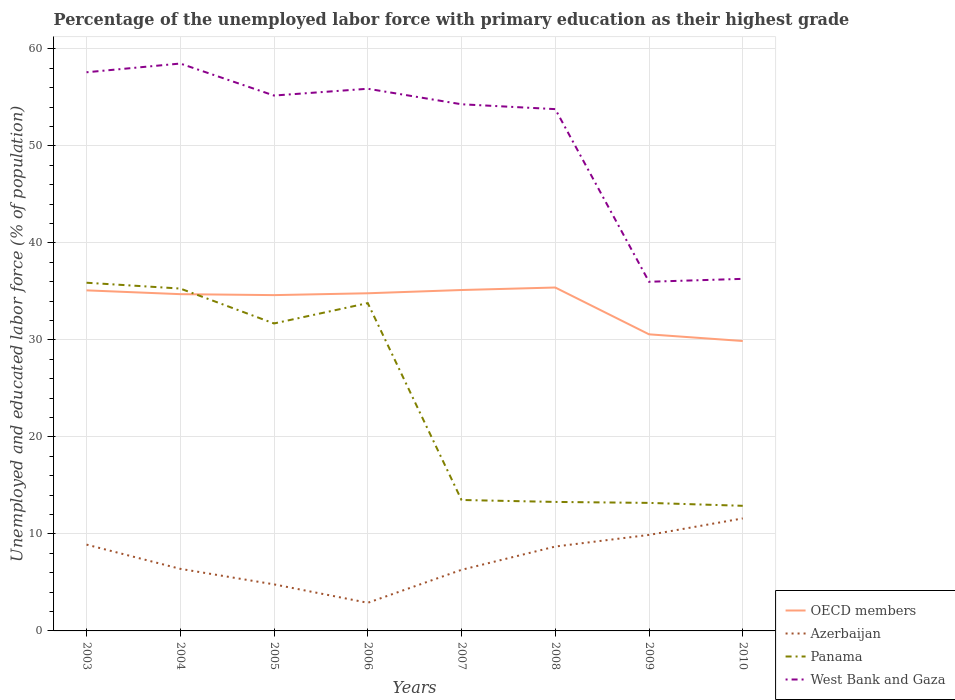How many different coloured lines are there?
Make the answer very short. 4. Is the number of lines equal to the number of legend labels?
Your answer should be very brief. Yes. What is the total percentage of the unemployed labor force with primary education in West Bank and Gaza in the graph?
Give a very brief answer. 21.6. What is the difference between the highest and the second highest percentage of the unemployed labor force with primary education in OECD members?
Ensure brevity in your answer.  5.51. Is the percentage of the unemployed labor force with primary education in OECD members strictly greater than the percentage of the unemployed labor force with primary education in West Bank and Gaza over the years?
Keep it short and to the point. Yes. How many lines are there?
Ensure brevity in your answer.  4. How many years are there in the graph?
Your answer should be compact. 8. Does the graph contain grids?
Your response must be concise. Yes. Where does the legend appear in the graph?
Provide a succinct answer. Bottom right. How many legend labels are there?
Make the answer very short. 4. What is the title of the graph?
Offer a very short reply. Percentage of the unemployed labor force with primary education as their highest grade. Does "Botswana" appear as one of the legend labels in the graph?
Ensure brevity in your answer.  No. What is the label or title of the Y-axis?
Your answer should be very brief. Unemployed and educated labor force (% of population). What is the Unemployed and educated labor force (% of population) in OECD members in 2003?
Offer a terse response. 35.11. What is the Unemployed and educated labor force (% of population) of Azerbaijan in 2003?
Keep it short and to the point. 8.9. What is the Unemployed and educated labor force (% of population) in Panama in 2003?
Make the answer very short. 35.9. What is the Unemployed and educated labor force (% of population) of West Bank and Gaza in 2003?
Your answer should be compact. 57.6. What is the Unemployed and educated labor force (% of population) of OECD members in 2004?
Provide a short and direct response. 34.72. What is the Unemployed and educated labor force (% of population) of Azerbaijan in 2004?
Provide a succinct answer. 6.4. What is the Unemployed and educated labor force (% of population) of Panama in 2004?
Your answer should be very brief. 35.3. What is the Unemployed and educated labor force (% of population) of West Bank and Gaza in 2004?
Your answer should be very brief. 58.5. What is the Unemployed and educated labor force (% of population) in OECD members in 2005?
Offer a terse response. 34.62. What is the Unemployed and educated labor force (% of population) of Azerbaijan in 2005?
Ensure brevity in your answer.  4.8. What is the Unemployed and educated labor force (% of population) in Panama in 2005?
Your answer should be compact. 31.7. What is the Unemployed and educated labor force (% of population) of West Bank and Gaza in 2005?
Your answer should be very brief. 55.2. What is the Unemployed and educated labor force (% of population) in OECD members in 2006?
Keep it short and to the point. 34.81. What is the Unemployed and educated labor force (% of population) in Azerbaijan in 2006?
Offer a very short reply. 2.9. What is the Unemployed and educated labor force (% of population) of Panama in 2006?
Ensure brevity in your answer.  33.8. What is the Unemployed and educated labor force (% of population) in West Bank and Gaza in 2006?
Your answer should be compact. 55.9. What is the Unemployed and educated labor force (% of population) of OECD members in 2007?
Offer a terse response. 35.15. What is the Unemployed and educated labor force (% of population) of Azerbaijan in 2007?
Keep it short and to the point. 6.3. What is the Unemployed and educated labor force (% of population) in Panama in 2007?
Provide a succinct answer. 13.5. What is the Unemployed and educated labor force (% of population) of West Bank and Gaza in 2007?
Keep it short and to the point. 54.3. What is the Unemployed and educated labor force (% of population) in OECD members in 2008?
Provide a short and direct response. 35.41. What is the Unemployed and educated labor force (% of population) of Azerbaijan in 2008?
Provide a succinct answer. 8.7. What is the Unemployed and educated labor force (% of population) of Panama in 2008?
Offer a terse response. 13.3. What is the Unemployed and educated labor force (% of population) of West Bank and Gaza in 2008?
Your answer should be very brief. 53.8. What is the Unemployed and educated labor force (% of population) in OECD members in 2009?
Offer a terse response. 30.58. What is the Unemployed and educated labor force (% of population) in Azerbaijan in 2009?
Give a very brief answer. 9.9. What is the Unemployed and educated labor force (% of population) of Panama in 2009?
Your answer should be very brief. 13.2. What is the Unemployed and educated labor force (% of population) of West Bank and Gaza in 2009?
Provide a short and direct response. 36. What is the Unemployed and educated labor force (% of population) of OECD members in 2010?
Give a very brief answer. 29.89. What is the Unemployed and educated labor force (% of population) in Azerbaijan in 2010?
Offer a terse response. 11.6. What is the Unemployed and educated labor force (% of population) in Panama in 2010?
Provide a succinct answer. 12.9. What is the Unemployed and educated labor force (% of population) of West Bank and Gaza in 2010?
Give a very brief answer. 36.3. Across all years, what is the maximum Unemployed and educated labor force (% of population) in OECD members?
Your response must be concise. 35.41. Across all years, what is the maximum Unemployed and educated labor force (% of population) in Azerbaijan?
Ensure brevity in your answer.  11.6. Across all years, what is the maximum Unemployed and educated labor force (% of population) of Panama?
Provide a short and direct response. 35.9. Across all years, what is the maximum Unemployed and educated labor force (% of population) in West Bank and Gaza?
Your answer should be very brief. 58.5. Across all years, what is the minimum Unemployed and educated labor force (% of population) in OECD members?
Provide a short and direct response. 29.89. Across all years, what is the minimum Unemployed and educated labor force (% of population) of Azerbaijan?
Your answer should be compact. 2.9. Across all years, what is the minimum Unemployed and educated labor force (% of population) of Panama?
Your answer should be compact. 12.9. What is the total Unemployed and educated labor force (% of population) in OECD members in the graph?
Provide a succinct answer. 270.3. What is the total Unemployed and educated labor force (% of population) of Azerbaijan in the graph?
Keep it short and to the point. 59.5. What is the total Unemployed and educated labor force (% of population) in Panama in the graph?
Offer a very short reply. 189.6. What is the total Unemployed and educated labor force (% of population) of West Bank and Gaza in the graph?
Provide a short and direct response. 407.6. What is the difference between the Unemployed and educated labor force (% of population) of OECD members in 2003 and that in 2004?
Your response must be concise. 0.39. What is the difference between the Unemployed and educated labor force (% of population) of Azerbaijan in 2003 and that in 2004?
Provide a succinct answer. 2.5. What is the difference between the Unemployed and educated labor force (% of population) of Panama in 2003 and that in 2004?
Your response must be concise. 0.6. What is the difference between the Unemployed and educated labor force (% of population) of OECD members in 2003 and that in 2005?
Give a very brief answer. 0.49. What is the difference between the Unemployed and educated labor force (% of population) of Azerbaijan in 2003 and that in 2005?
Your response must be concise. 4.1. What is the difference between the Unemployed and educated labor force (% of population) of Panama in 2003 and that in 2005?
Your answer should be compact. 4.2. What is the difference between the Unemployed and educated labor force (% of population) in OECD members in 2003 and that in 2006?
Offer a terse response. 0.3. What is the difference between the Unemployed and educated labor force (% of population) in Panama in 2003 and that in 2006?
Provide a succinct answer. 2.1. What is the difference between the Unemployed and educated labor force (% of population) of West Bank and Gaza in 2003 and that in 2006?
Keep it short and to the point. 1.7. What is the difference between the Unemployed and educated labor force (% of population) in OECD members in 2003 and that in 2007?
Give a very brief answer. -0.04. What is the difference between the Unemployed and educated labor force (% of population) in Panama in 2003 and that in 2007?
Your answer should be very brief. 22.4. What is the difference between the Unemployed and educated labor force (% of population) in West Bank and Gaza in 2003 and that in 2007?
Offer a very short reply. 3.3. What is the difference between the Unemployed and educated labor force (% of population) of OECD members in 2003 and that in 2008?
Provide a succinct answer. -0.29. What is the difference between the Unemployed and educated labor force (% of population) in Panama in 2003 and that in 2008?
Your answer should be very brief. 22.6. What is the difference between the Unemployed and educated labor force (% of population) of OECD members in 2003 and that in 2009?
Provide a short and direct response. 4.53. What is the difference between the Unemployed and educated labor force (% of population) in Azerbaijan in 2003 and that in 2009?
Provide a short and direct response. -1. What is the difference between the Unemployed and educated labor force (% of population) of Panama in 2003 and that in 2009?
Offer a terse response. 22.7. What is the difference between the Unemployed and educated labor force (% of population) in West Bank and Gaza in 2003 and that in 2009?
Your answer should be compact. 21.6. What is the difference between the Unemployed and educated labor force (% of population) in OECD members in 2003 and that in 2010?
Offer a terse response. 5.22. What is the difference between the Unemployed and educated labor force (% of population) of Panama in 2003 and that in 2010?
Provide a succinct answer. 23. What is the difference between the Unemployed and educated labor force (% of population) in West Bank and Gaza in 2003 and that in 2010?
Make the answer very short. 21.3. What is the difference between the Unemployed and educated labor force (% of population) in OECD members in 2004 and that in 2005?
Your answer should be very brief. 0.1. What is the difference between the Unemployed and educated labor force (% of population) of OECD members in 2004 and that in 2006?
Provide a succinct answer. -0.09. What is the difference between the Unemployed and educated labor force (% of population) of Azerbaijan in 2004 and that in 2006?
Offer a terse response. 3.5. What is the difference between the Unemployed and educated labor force (% of population) of West Bank and Gaza in 2004 and that in 2006?
Ensure brevity in your answer.  2.6. What is the difference between the Unemployed and educated labor force (% of population) in OECD members in 2004 and that in 2007?
Provide a succinct answer. -0.43. What is the difference between the Unemployed and educated labor force (% of population) of Panama in 2004 and that in 2007?
Provide a succinct answer. 21.8. What is the difference between the Unemployed and educated labor force (% of population) in OECD members in 2004 and that in 2008?
Your answer should be compact. -0.68. What is the difference between the Unemployed and educated labor force (% of population) in Azerbaijan in 2004 and that in 2008?
Provide a short and direct response. -2.3. What is the difference between the Unemployed and educated labor force (% of population) of OECD members in 2004 and that in 2009?
Keep it short and to the point. 4.14. What is the difference between the Unemployed and educated labor force (% of population) of Panama in 2004 and that in 2009?
Your answer should be very brief. 22.1. What is the difference between the Unemployed and educated labor force (% of population) of West Bank and Gaza in 2004 and that in 2009?
Keep it short and to the point. 22.5. What is the difference between the Unemployed and educated labor force (% of population) of OECD members in 2004 and that in 2010?
Offer a very short reply. 4.83. What is the difference between the Unemployed and educated labor force (% of population) of Azerbaijan in 2004 and that in 2010?
Ensure brevity in your answer.  -5.2. What is the difference between the Unemployed and educated labor force (% of population) of Panama in 2004 and that in 2010?
Your answer should be very brief. 22.4. What is the difference between the Unemployed and educated labor force (% of population) in West Bank and Gaza in 2004 and that in 2010?
Keep it short and to the point. 22.2. What is the difference between the Unemployed and educated labor force (% of population) of OECD members in 2005 and that in 2006?
Your answer should be very brief. -0.19. What is the difference between the Unemployed and educated labor force (% of population) in Azerbaijan in 2005 and that in 2006?
Your answer should be compact. 1.9. What is the difference between the Unemployed and educated labor force (% of population) in Panama in 2005 and that in 2006?
Your response must be concise. -2.1. What is the difference between the Unemployed and educated labor force (% of population) in West Bank and Gaza in 2005 and that in 2006?
Provide a short and direct response. -0.7. What is the difference between the Unemployed and educated labor force (% of population) of OECD members in 2005 and that in 2007?
Ensure brevity in your answer.  -0.53. What is the difference between the Unemployed and educated labor force (% of population) of Panama in 2005 and that in 2007?
Your answer should be compact. 18.2. What is the difference between the Unemployed and educated labor force (% of population) of West Bank and Gaza in 2005 and that in 2007?
Keep it short and to the point. 0.9. What is the difference between the Unemployed and educated labor force (% of population) of OECD members in 2005 and that in 2008?
Provide a short and direct response. -0.78. What is the difference between the Unemployed and educated labor force (% of population) in Azerbaijan in 2005 and that in 2008?
Provide a short and direct response. -3.9. What is the difference between the Unemployed and educated labor force (% of population) of Panama in 2005 and that in 2008?
Your answer should be compact. 18.4. What is the difference between the Unemployed and educated labor force (% of population) of OECD members in 2005 and that in 2009?
Your answer should be very brief. 4.04. What is the difference between the Unemployed and educated labor force (% of population) in Azerbaijan in 2005 and that in 2009?
Give a very brief answer. -5.1. What is the difference between the Unemployed and educated labor force (% of population) of West Bank and Gaza in 2005 and that in 2009?
Provide a succinct answer. 19.2. What is the difference between the Unemployed and educated labor force (% of population) of OECD members in 2005 and that in 2010?
Offer a very short reply. 4.73. What is the difference between the Unemployed and educated labor force (% of population) of Azerbaijan in 2005 and that in 2010?
Offer a terse response. -6.8. What is the difference between the Unemployed and educated labor force (% of population) in Panama in 2005 and that in 2010?
Provide a succinct answer. 18.8. What is the difference between the Unemployed and educated labor force (% of population) of West Bank and Gaza in 2005 and that in 2010?
Offer a very short reply. 18.9. What is the difference between the Unemployed and educated labor force (% of population) in OECD members in 2006 and that in 2007?
Provide a succinct answer. -0.34. What is the difference between the Unemployed and educated labor force (% of population) in Azerbaijan in 2006 and that in 2007?
Offer a terse response. -3.4. What is the difference between the Unemployed and educated labor force (% of population) of Panama in 2006 and that in 2007?
Your answer should be very brief. 20.3. What is the difference between the Unemployed and educated labor force (% of population) of West Bank and Gaza in 2006 and that in 2007?
Provide a short and direct response. 1.6. What is the difference between the Unemployed and educated labor force (% of population) in OECD members in 2006 and that in 2008?
Offer a very short reply. -0.59. What is the difference between the Unemployed and educated labor force (% of population) in Panama in 2006 and that in 2008?
Your answer should be very brief. 20.5. What is the difference between the Unemployed and educated labor force (% of population) in OECD members in 2006 and that in 2009?
Give a very brief answer. 4.23. What is the difference between the Unemployed and educated labor force (% of population) in Azerbaijan in 2006 and that in 2009?
Offer a terse response. -7. What is the difference between the Unemployed and educated labor force (% of population) in Panama in 2006 and that in 2009?
Offer a terse response. 20.6. What is the difference between the Unemployed and educated labor force (% of population) in OECD members in 2006 and that in 2010?
Provide a succinct answer. 4.92. What is the difference between the Unemployed and educated labor force (% of population) in Azerbaijan in 2006 and that in 2010?
Offer a very short reply. -8.7. What is the difference between the Unemployed and educated labor force (% of population) in Panama in 2006 and that in 2010?
Offer a very short reply. 20.9. What is the difference between the Unemployed and educated labor force (% of population) of West Bank and Gaza in 2006 and that in 2010?
Your answer should be very brief. 19.6. What is the difference between the Unemployed and educated labor force (% of population) of OECD members in 2007 and that in 2008?
Give a very brief answer. -0.26. What is the difference between the Unemployed and educated labor force (% of population) of West Bank and Gaza in 2007 and that in 2008?
Offer a very short reply. 0.5. What is the difference between the Unemployed and educated labor force (% of population) of OECD members in 2007 and that in 2009?
Your response must be concise. 4.57. What is the difference between the Unemployed and educated labor force (% of population) of Panama in 2007 and that in 2009?
Ensure brevity in your answer.  0.3. What is the difference between the Unemployed and educated labor force (% of population) in OECD members in 2007 and that in 2010?
Your response must be concise. 5.26. What is the difference between the Unemployed and educated labor force (% of population) in Panama in 2007 and that in 2010?
Give a very brief answer. 0.6. What is the difference between the Unemployed and educated labor force (% of population) in OECD members in 2008 and that in 2009?
Provide a succinct answer. 4.83. What is the difference between the Unemployed and educated labor force (% of population) of OECD members in 2008 and that in 2010?
Your answer should be compact. 5.51. What is the difference between the Unemployed and educated labor force (% of population) in Azerbaijan in 2008 and that in 2010?
Make the answer very short. -2.9. What is the difference between the Unemployed and educated labor force (% of population) of Panama in 2008 and that in 2010?
Your answer should be compact. 0.4. What is the difference between the Unemployed and educated labor force (% of population) of OECD members in 2009 and that in 2010?
Your response must be concise. 0.69. What is the difference between the Unemployed and educated labor force (% of population) of Panama in 2009 and that in 2010?
Your answer should be very brief. 0.3. What is the difference between the Unemployed and educated labor force (% of population) of West Bank and Gaza in 2009 and that in 2010?
Give a very brief answer. -0.3. What is the difference between the Unemployed and educated labor force (% of population) in OECD members in 2003 and the Unemployed and educated labor force (% of population) in Azerbaijan in 2004?
Your answer should be compact. 28.71. What is the difference between the Unemployed and educated labor force (% of population) of OECD members in 2003 and the Unemployed and educated labor force (% of population) of Panama in 2004?
Ensure brevity in your answer.  -0.19. What is the difference between the Unemployed and educated labor force (% of population) in OECD members in 2003 and the Unemployed and educated labor force (% of population) in West Bank and Gaza in 2004?
Your answer should be very brief. -23.39. What is the difference between the Unemployed and educated labor force (% of population) in Azerbaijan in 2003 and the Unemployed and educated labor force (% of population) in Panama in 2004?
Give a very brief answer. -26.4. What is the difference between the Unemployed and educated labor force (% of population) of Azerbaijan in 2003 and the Unemployed and educated labor force (% of population) of West Bank and Gaza in 2004?
Your answer should be compact. -49.6. What is the difference between the Unemployed and educated labor force (% of population) of Panama in 2003 and the Unemployed and educated labor force (% of population) of West Bank and Gaza in 2004?
Keep it short and to the point. -22.6. What is the difference between the Unemployed and educated labor force (% of population) in OECD members in 2003 and the Unemployed and educated labor force (% of population) in Azerbaijan in 2005?
Your answer should be compact. 30.31. What is the difference between the Unemployed and educated labor force (% of population) of OECD members in 2003 and the Unemployed and educated labor force (% of population) of Panama in 2005?
Your response must be concise. 3.41. What is the difference between the Unemployed and educated labor force (% of population) in OECD members in 2003 and the Unemployed and educated labor force (% of population) in West Bank and Gaza in 2005?
Your answer should be compact. -20.09. What is the difference between the Unemployed and educated labor force (% of population) in Azerbaijan in 2003 and the Unemployed and educated labor force (% of population) in Panama in 2005?
Ensure brevity in your answer.  -22.8. What is the difference between the Unemployed and educated labor force (% of population) of Azerbaijan in 2003 and the Unemployed and educated labor force (% of population) of West Bank and Gaza in 2005?
Provide a short and direct response. -46.3. What is the difference between the Unemployed and educated labor force (% of population) in Panama in 2003 and the Unemployed and educated labor force (% of population) in West Bank and Gaza in 2005?
Your response must be concise. -19.3. What is the difference between the Unemployed and educated labor force (% of population) in OECD members in 2003 and the Unemployed and educated labor force (% of population) in Azerbaijan in 2006?
Your response must be concise. 32.21. What is the difference between the Unemployed and educated labor force (% of population) of OECD members in 2003 and the Unemployed and educated labor force (% of population) of Panama in 2006?
Your answer should be compact. 1.31. What is the difference between the Unemployed and educated labor force (% of population) in OECD members in 2003 and the Unemployed and educated labor force (% of population) in West Bank and Gaza in 2006?
Your answer should be compact. -20.79. What is the difference between the Unemployed and educated labor force (% of population) of Azerbaijan in 2003 and the Unemployed and educated labor force (% of population) of Panama in 2006?
Provide a short and direct response. -24.9. What is the difference between the Unemployed and educated labor force (% of population) of Azerbaijan in 2003 and the Unemployed and educated labor force (% of population) of West Bank and Gaza in 2006?
Keep it short and to the point. -47. What is the difference between the Unemployed and educated labor force (% of population) of OECD members in 2003 and the Unemployed and educated labor force (% of population) of Azerbaijan in 2007?
Give a very brief answer. 28.81. What is the difference between the Unemployed and educated labor force (% of population) of OECD members in 2003 and the Unemployed and educated labor force (% of population) of Panama in 2007?
Offer a terse response. 21.61. What is the difference between the Unemployed and educated labor force (% of population) in OECD members in 2003 and the Unemployed and educated labor force (% of population) in West Bank and Gaza in 2007?
Keep it short and to the point. -19.19. What is the difference between the Unemployed and educated labor force (% of population) in Azerbaijan in 2003 and the Unemployed and educated labor force (% of population) in West Bank and Gaza in 2007?
Keep it short and to the point. -45.4. What is the difference between the Unemployed and educated labor force (% of population) in Panama in 2003 and the Unemployed and educated labor force (% of population) in West Bank and Gaza in 2007?
Give a very brief answer. -18.4. What is the difference between the Unemployed and educated labor force (% of population) of OECD members in 2003 and the Unemployed and educated labor force (% of population) of Azerbaijan in 2008?
Your response must be concise. 26.41. What is the difference between the Unemployed and educated labor force (% of population) in OECD members in 2003 and the Unemployed and educated labor force (% of population) in Panama in 2008?
Provide a succinct answer. 21.81. What is the difference between the Unemployed and educated labor force (% of population) of OECD members in 2003 and the Unemployed and educated labor force (% of population) of West Bank and Gaza in 2008?
Offer a very short reply. -18.69. What is the difference between the Unemployed and educated labor force (% of population) in Azerbaijan in 2003 and the Unemployed and educated labor force (% of population) in Panama in 2008?
Your answer should be very brief. -4.4. What is the difference between the Unemployed and educated labor force (% of population) in Azerbaijan in 2003 and the Unemployed and educated labor force (% of population) in West Bank and Gaza in 2008?
Ensure brevity in your answer.  -44.9. What is the difference between the Unemployed and educated labor force (% of population) in Panama in 2003 and the Unemployed and educated labor force (% of population) in West Bank and Gaza in 2008?
Make the answer very short. -17.9. What is the difference between the Unemployed and educated labor force (% of population) in OECD members in 2003 and the Unemployed and educated labor force (% of population) in Azerbaijan in 2009?
Keep it short and to the point. 25.21. What is the difference between the Unemployed and educated labor force (% of population) of OECD members in 2003 and the Unemployed and educated labor force (% of population) of Panama in 2009?
Make the answer very short. 21.91. What is the difference between the Unemployed and educated labor force (% of population) in OECD members in 2003 and the Unemployed and educated labor force (% of population) in West Bank and Gaza in 2009?
Your answer should be compact. -0.89. What is the difference between the Unemployed and educated labor force (% of population) in Azerbaijan in 2003 and the Unemployed and educated labor force (% of population) in Panama in 2009?
Provide a succinct answer. -4.3. What is the difference between the Unemployed and educated labor force (% of population) in Azerbaijan in 2003 and the Unemployed and educated labor force (% of population) in West Bank and Gaza in 2009?
Your answer should be very brief. -27.1. What is the difference between the Unemployed and educated labor force (% of population) in OECD members in 2003 and the Unemployed and educated labor force (% of population) in Azerbaijan in 2010?
Ensure brevity in your answer.  23.51. What is the difference between the Unemployed and educated labor force (% of population) in OECD members in 2003 and the Unemployed and educated labor force (% of population) in Panama in 2010?
Ensure brevity in your answer.  22.21. What is the difference between the Unemployed and educated labor force (% of population) of OECD members in 2003 and the Unemployed and educated labor force (% of population) of West Bank and Gaza in 2010?
Provide a short and direct response. -1.19. What is the difference between the Unemployed and educated labor force (% of population) in Azerbaijan in 2003 and the Unemployed and educated labor force (% of population) in Panama in 2010?
Keep it short and to the point. -4. What is the difference between the Unemployed and educated labor force (% of population) of Azerbaijan in 2003 and the Unemployed and educated labor force (% of population) of West Bank and Gaza in 2010?
Your answer should be very brief. -27.4. What is the difference between the Unemployed and educated labor force (% of population) in OECD members in 2004 and the Unemployed and educated labor force (% of population) in Azerbaijan in 2005?
Keep it short and to the point. 29.92. What is the difference between the Unemployed and educated labor force (% of population) in OECD members in 2004 and the Unemployed and educated labor force (% of population) in Panama in 2005?
Ensure brevity in your answer.  3.02. What is the difference between the Unemployed and educated labor force (% of population) in OECD members in 2004 and the Unemployed and educated labor force (% of population) in West Bank and Gaza in 2005?
Your answer should be compact. -20.48. What is the difference between the Unemployed and educated labor force (% of population) in Azerbaijan in 2004 and the Unemployed and educated labor force (% of population) in Panama in 2005?
Offer a terse response. -25.3. What is the difference between the Unemployed and educated labor force (% of population) of Azerbaijan in 2004 and the Unemployed and educated labor force (% of population) of West Bank and Gaza in 2005?
Provide a short and direct response. -48.8. What is the difference between the Unemployed and educated labor force (% of population) of Panama in 2004 and the Unemployed and educated labor force (% of population) of West Bank and Gaza in 2005?
Give a very brief answer. -19.9. What is the difference between the Unemployed and educated labor force (% of population) of OECD members in 2004 and the Unemployed and educated labor force (% of population) of Azerbaijan in 2006?
Give a very brief answer. 31.82. What is the difference between the Unemployed and educated labor force (% of population) in OECD members in 2004 and the Unemployed and educated labor force (% of population) in Panama in 2006?
Ensure brevity in your answer.  0.92. What is the difference between the Unemployed and educated labor force (% of population) of OECD members in 2004 and the Unemployed and educated labor force (% of population) of West Bank and Gaza in 2006?
Keep it short and to the point. -21.18. What is the difference between the Unemployed and educated labor force (% of population) of Azerbaijan in 2004 and the Unemployed and educated labor force (% of population) of Panama in 2006?
Make the answer very short. -27.4. What is the difference between the Unemployed and educated labor force (% of population) in Azerbaijan in 2004 and the Unemployed and educated labor force (% of population) in West Bank and Gaza in 2006?
Your answer should be compact. -49.5. What is the difference between the Unemployed and educated labor force (% of population) of Panama in 2004 and the Unemployed and educated labor force (% of population) of West Bank and Gaza in 2006?
Provide a succinct answer. -20.6. What is the difference between the Unemployed and educated labor force (% of population) of OECD members in 2004 and the Unemployed and educated labor force (% of population) of Azerbaijan in 2007?
Your answer should be compact. 28.42. What is the difference between the Unemployed and educated labor force (% of population) of OECD members in 2004 and the Unemployed and educated labor force (% of population) of Panama in 2007?
Make the answer very short. 21.22. What is the difference between the Unemployed and educated labor force (% of population) of OECD members in 2004 and the Unemployed and educated labor force (% of population) of West Bank and Gaza in 2007?
Offer a very short reply. -19.58. What is the difference between the Unemployed and educated labor force (% of population) of Azerbaijan in 2004 and the Unemployed and educated labor force (% of population) of Panama in 2007?
Ensure brevity in your answer.  -7.1. What is the difference between the Unemployed and educated labor force (% of population) in Azerbaijan in 2004 and the Unemployed and educated labor force (% of population) in West Bank and Gaza in 2007?
Your response must be concise. -47.9. What is the difference between the Unemployed and educated labor force (% of population) of OECD members in 2004 and the Unemployed and educated labor force (% of population) of Azerbaijan in 2008?
Ensure brevity in your answer.  26.02. What is the difference between the Unemployed and educated labor force (% of population) in OECD members in 2004 and the Unemployed and educated labor force (% of population) in Panama in 2008?
Offer a terse response. 21.42. What is the difference between the Unemployed and educated labor force (% of population) of OECD members in 2004 and the Unemployed and educated labor force (% of population) of West Bank and Gaza in 2008?
Your answer should be very brief. -19.08. What is the difference between the Unemployed and educated labor force (% of population) of Azerbaijan in 2004 and the Unemployed and educated labor force (% of population) of Panama in 2008?
Provide a short and direct response. -6.9. What is the difference between the Unemployed and educated labor force (% of population) in Azerbaijan in 2004 and the Unemployed and educated labor force (% of population) in West Bank and Gaza in 2008?
Your answer should be compact. -47.4. What is the difference between the Unemployed and educated labor force (% of population) in Panama in 2004 and the Unemployed and educated labor force (% of population) in West Bank and Gaza in 2008?
Your answer should be very brief. -18.5. What is the difference between the Unemployed and educated labor force (% of population) in OECD members in 2004 and the Unemployed and educated labor force (% of population) in Azerbaijan in 2009?
Offer a very short reply. 24.82. What is the difference between the Unemployed and educated labor force (% of population) in OECD members in 2004 and the Unemployed and educated labor force (% of population) in Panama in 2009?
Make the answer very short. 21.52. What is the difference between the Unemployed and educated labor force (% of population) of OECD members in 2004 and the Unemployed and educated labor force (% of population) of West Bank and Gaza in 2009?
Your answer should be compact. -1.28. What is the difference between the Unemployed and educated labor force (% of population) of Azerbaijan in 2004 and the Unemployed and educated labor force (% of population) of Panama in 2009?
Your answer should be very brief. -6.8. What is the difference between the Unemployed and educated labor force (% of population) in Azerbaijan in 2004 and the Unemployed and educated labor force (% of population) in West Bank and Gaza in 2009?
Offer a very short reply. -29.6. What is the difference between the Unemployed and educated labor force (% of population) of OECD members in 2004 and the Unemployed and educated labor force (% of population) of Azerbaijan in 2010?
Offer a very short reply. 23.12. What is the difference between the Unemployed and educated labor force (% of population) in OECD members in 2004 and the Unemployed and educated labor force (% of population) in Panama in 2010?
Your answer should be very brief. 21.82. What is the difference between the Unemployed and educated labor force (% of population) in OECD members in 2004 and the Unemployed and educated labor force (% of population) in West Bank and Gaza in 2010?
Offer a very short reply. -1.58. What is the difference between the Unemployed and educated labor force (% of population) in Azerbaijan in 2004 and the Unemployed and educated labor force (% of population) in Panama in 2010?
Your answer should be compact. -6.5. What is the difference between the Unemployed and educated labor force (% of population) in Azerbaijan in 2004 and the Unemployed and educated labor force (% of population) in West Bank and Gaza in 2010?
Make the answer very short. -29.9. What is the difference between the Unemployed and educated labor force (% of population) of OECD members in 2005 and the Unemployed and educated labor force (% of population) of Azerbaijan in 2006?
Keep it short and to the point. 31.72. What is the difference between the Unemployed and educated labor force (% of population) in OECD members in 2005 and the Unemployed and educated labor force (% of population) in Panama in 2006?
Give a very brief answer. 0.82. What is the difference between the Unemployed and educated labor force (% of population) of OECD members in 2005 and the Unemployed and educated labor force (% of population) of West Bank and Gaza in 2006?
Give a very brief answer. -21.28. What is the difference between the Unemployed and educated labor force (% of population) in Azerbaijan in 2005 and the Unemployed and educated labor force (% of population) in West Bank and Gaza in 2006?
Give a very brief answer. -51.1. What is the difference between the Unemployed and educated labor force (% of population) in Panama in 2005 and the Unemployed and educated labor force (% of population) in West Bank and Gaza in 2006?
Your response must be concise. -24.2. What is the difference between the Unemployed and educated labor force (% of population) in OECD members in 2005 and the Unemployed and educated labor force (% of population) in Azerbaijan in 2007?
Offer a terse response. 28.32. What is the difference between the Unemployed and educated labor force (% of population) in OECD members in 2005 and the Unemployed and educated labor force (% of population) in Panama in 2007?
Provide a short and direct response. 21.12. What is the difference between the Unemployed and educated labor force (% of population) in OECD members in 2005 and the Unemployed and educated labor force (% of population) in West Bank and Gaza in 2007?
Give a very brief answer. -19.68. What is the difference between the Unemployed and educated labor force (% of population) of Azerbaijan in 2005 and the Unemployed and educated labor force (% of population) of West Bank and Gaza in 2007?
Make the answer very short. -49.5. What is the difference between the Unemployed and educated labor force (% of population) of Panama in 2005 and the Unemployed and educated labor force (% of population) of West Bank and Gaza in 2007?
Your answer should be compact. -22.6. What is the difference between the Unemployed and educated labor force (% of population) of OECD members in 2005 and the Unemployed and educated labor force (% of population) of Azerbaijan in 2008?
Provide a succinct answer. 25.92. What is the difference between the Unemployed and educated labor force (% of population) of OECD members in 2005 and the Unemployed and educated labor force (% of population) of Panama in 2008?
Offer a very short reply. 21.32. What is the difference between the Unemployed and educated labor force (% of population) of OECD members in 2005 and the Unemployed and educated labor force (% of population) of West Bank and Gaza in 2008?
Offer a very short reply. -19.18. What is the difference between the Unemployed and educated labor force (% of population) in Azerbaijan in 2005 and the Unemployed and educated labor force (% of population) in Panama in 2008?
Ensure brevity in your answer.  -8.5. What is the difference between the Unemployed and educated labor force (% of population) of Azerbaijan in 2005 and the Unemployed and educated labor force (% of population) of West Bank and Gaza in 2008?
Give a very brief answer. -49. What is the difference between the Unemployed and educated labor force (% of population) of Panama in 2005 and the Unemployed and educated labor force (% of population) of West Bank and Gaza in 2008?
Give a very brief answer. -22.1. What is the difference between the Unemployed and educated labor force (% of population) in OECD members in 2005 and the Unemployed and educated labor force (% of population) in Azerbaijan in 2009?
Give a very brief answer. 24.72. What is the difference between the Unemployed and educated labor force (% of population) of OECD members in 2005 and the Unemployed and educated labor force (% of population) of Panama in 2009?
Ensure brevity in your answer.  21.42. What is the difference between the Unemployed and educated labor force (% of population) of OECD members in 2005 and the Unemployed and educated labor force (% of population) of West Bank and Gaza in 2009?
Make the answer very short. -1.38. What is the difference between the Unemployed and educated labor force (% of population) in Azerbaijan in 2005 and the Unemployed and educated labor force (% of population) in West Bank and Gaza in 2009?
Provide a succinct answer. -31.2. What is the difference between the Unemployed and educated labor force (% of population) in OECD members in 2005 and the Unemployed and educated labor force (% of population) in Azerbaijan in 2010?
Make the answer very short. 23.02. What is the difference between the Unemployed and educated labor force (% of population) in OECD members in 2005 and the Unemployed and educated labor force (% of population) in Panama in 2010?
Provide a short and direct response. 21.72. What is the difference between the Unemployed and educated labor force (% of population) in OECD members in 2005 and the Unemployed and educated labor force (% of population) in West Bank and Gaza in 2010?
Ensure brevity in your answer.  -1.68. What is the difference between the Unemployed and educated labor force (% of population) in Azerbaijan in 2005 and the Unemployed and educated labor force (% of population) in West Bank and Gaza in 2010?
Your answer should be compact. -31.5. What is the difference between the Unemployed and educated labor force (% of population) in OECD members in 2006 and the Unemployed and educated labor force (% of population) in Azerbaijan in 2007?
Ensure brevity in your answer.  28.51. What is the difference between the Unemployed and educated labor force (% of population) in OECD members in 2006 and the Unemployed and educated labor force (% of population) in Panama in 2007?
Your answer should be compact. 21.31. What is the difference between the Unemployed and educated labor force (% of population) in OECD members in 2006 and the Unemployed and educated labor force (% of population) in West Bank and Gaza in 2007?
Your answer should be very brief. -19.49. What is the difference between the Unemployed and educated labor force (% of population) in Azerbaijan in 2006 and the Unemployed and educated labor force (% of population) in Panama in 2007?
Offer a very short reply. -10.6. What is the difference between the Unemployed and educated labor force (% of population) of Azerbaijan in 2006 and the Unemployed and educated labor force (% of population) of West Bank and Gaza in 2007?
Provide a succinct answer. -51.4. What is the difference between the Unemployed and educated labor force (% of population) in Panama in 2006 and the Unemployed and educated labor force (% of population) in West Bank and Gaza in 2007?
Your answer should be very brief. -20.5. What is the difference between the Unemployed and educated labor force (% of population) of OECD members in 2006 and the Unemployed and educated labor force (% of population) of Azerbaijan in 2008?
Provide a succinct answer. 26.11. What is the difference between the Unemployed and educated labor force (% of population) of OECD members in 2006 and the Unemployed and educated labor force (% of population) of Panama in 2008?
Keep it short and to the point. 21.51. What is the difference between the Unemployed and educated labor force (% of population) of OECD members in 2006 and the Unemployed and educated labor force (% of population) of West Bank and Gaza in 2008?
Your answer should be compact. -18.99. What is the difference between the Unemployed and educated labor force (% of population) of Azerbaijan in 2006 and the Unemployed and educated labor force (% of population) of Panama in 2008?
Your answer should be compact. -10.4. What is the difference between the Unemployed and educated labor force (% of population) of Azerbaijan in 2006 and the Unemployed and educated labor force (% of population) of West Bank and Gaza in 2008?
Provide a succinct answer. -50.9. What is the difference between the Unemployed and educated labor force (% of population) of Panama in 2006 and the Unemployed and educated labor force (% of population) of West Bank and Gaza in 2008?
Your response must be concise. -20. What is the difference between the Unemployed and educated labor force (% of population) in OECD members in 2006 and the Unemployed and educated labor force (% of population) in Azerbaijan in 2009?
Give a very brief answer. 24.91. What is the difference between the Unemployed and educated labor force (% of population) in OECD members in 2006 and the Unemployed and educated labor force (% of population) in Panama in 2009?
Keep it short and to the point. 21.61. What is the difference between the Unemployed and educated labor force (% of population) of OECD members in 2006 and the Unemployed and educated labor force (% of population) of West Bank and Gaza in 2009?
Your answer should be compact. -1.19. What is the difference between the Unemployed and educated labor force (% of population) of Azerbaijan in 2006 and the Unemployed and educated labor force (% of population) of West Bank and Gaza in 2009?
Your answer should be very brief. -33.1. What is the difference between the Unemployed and educated labor force (% of population) in OECD members in 2006 and the Unemployed and educated labor force (% of population) in Azerbaijan in 2010?
Provide a succinct answer. 23.21. What is the difference between the Unemployed and educated labor force (% of population) in OECD members in 2006 and the Unemployed and educated labor force (% of population) in Panama in 2010?
Your answer should be very brief. 21.91. What is the difference between the Unemployed and educated labor force (% of population) in OECD members in 2006 and the Unemployed and educated labor force (% of population) in West Bank and Gaza in 2010?
Your answer should be compact. -1.49. What is the difference between the Unemployed and educated labor force (% of population) of Azerbaijan in 2006 and the Unemployed and educated labor force (% of population) of West Bank and Gaza in 2010?
Ensure brevity in your answer.  -33.4. What is the difference between the Unemployed and educated labor force (% of population) of Panama in 2006 and the Unemployed and educated labor force (% of population) of West Bank and Gaza in 2010?
Your response must be concise. -2.5. What is the difference between the Unemployed and educated labor force (% of population) of OECD members in 2007 and the Unemployed and educated labor force (% of population) of Azerbaijan in 2008?
Provide a succinct answer. 26.45. What is the difference between the Unemployed and educated labor force (% of population) of OECD members in 2007 and the Unemployed and educated labor force (% of population) of Panama in 2008?
Make the answer very short. 21.85. What is the difference between the Unemployed and educated labor force (% of population) in OECD members in 2007 and the Unemployed and educated labor force (% of population) in West Bank and Gaza in 2008?
Make the answer very short. -18.65. What is the difference between the Unemployed and educated labor force (% of population) in Azerbaijan in 2007 and the Unemployed and educated labor force (% of population) in West Bank and Gaza in 2008?
Your answer should be very brief. -47.5. What is the difference between the Unemployed and educated labor force (% of population) in Panama in 2007 and the Unemployed and educated labor force (% of population) in West Bank and Gaza in 2008?
Offer a terse response. -40.3. What is the difference between the Unemployed and educated labor force (% of population) in OECD members in 2007 and the Unemployed and educated labor force (% of population) in Azerbaijan in 2009?
Your response must be concise. 25.25. What is the difference between the Unemployed and educated labor force (% of population) in OECD members in 2007 and the Unemployed and educated labor force (% of population) in Panama in 2009?
Ensure brevity in your answer.  21.95. What is the difference between the Unemployed and educated labor force (% of population) in OECD members in 2007 and the Unemployed and educated labor force (% of population) in West Bank and Gaza in 2009?
Offer a terse response. -0.85. What is the difference between the Unemployed and educated labor force (% of population) of Azerbaijan in 2007 and the Unemployed and educated labor force (% of population) of Panama in 2009?
Provide a short and direct response. -6.9. What is the difference between the Unemployed and educated labor force (% of population) in Azerbaijan in 2007 and the Unemployed and educated labor force (% of population) in West Bank and Gaza in 2009?
Your answer should be very brief. -29.7. What is the difference between the Unemployed and educated labor force (% of population) in Panama in 2007 and the Unemployed and educated labor force (% of population) in West Bank and Gaza in 2009?
Offer a very short reply. -22.5. What is the difference between the Unemployed and educated labor force (% of population) of OECD members in 2007 and the Unemployed and educated labor force (% of population) of Azerbaijan in 2010?
Provide a succinct answer. 23.55. What is the difference between the Unemployed and educated labor force (% of population) of OECD members in 2007 and the Unemployed and educated labor force (% of population) of Panama in 2010?
Provide a short and direct response. 22.25. What is the difference between the Unemployed and educated labor force (% of population) in OECD members in 2007 and the Unemployed and educated labor force (% of population) in West Bank and Gaza in 2010?
Ensure brevity in your answer.  -1.15. What is the difference between the Unemployed and educated labor force (% of population) of Azerbaijan in 2007 and the Unemployed and educated labor force (% of population) of Panama in 2010?
Provide a succinct answer. -6.6. What is the difference between the Unemployed and educated labor force (% of population) of Azerbaijan in 2007 and the Unemployed and educated labor force (% of population) of West Bank and Gaza in 2010?
Your answer should be compact. -30. What is the difference between the Unemployed and educated labor force (% of population) in Panama in 2007 and the Unemployed and educated labor force (% of population) in West Bank and Gaza in 2010?
Give a very brief answer. -22.8. What is the difference between the Unemployed and educated labor force (% of population) of OECD members in 2008 and the Unemployed and educated labor force (% of population) of Azerbaijan in 2009?
Give a very brief answer. 25.51. What is the difference between the Unemployed and educated labor force (% of population) in OECD members in 2008 and the Unemployed and educated labor force (% of population) in Panama in 2009?
Keep it short and to the point. 22.21. What is the difference between the Unemployed and educated labor force (% of population) of OECD members in 2008 and the Unemployed and educated labor force (% of population) of West Bank and Gaza in 2009?
Your answer should be compact. -0.59. What is the difference between the Unemployed and educated labor force (% of population) in Azerbaijan in 2008 and the Unemployed and educated labor force (% of population) in West Bank and Gaza in 2009?
Ensure brevity in your answer.  -27.3. What is the difference between the Unemployed and educated labor force (% of population) in Panama in 2008 and the Unemployed and educated labor force (% of population) in West Bank and Gaza in 2009?
Ensure brevity in your answer.  -22.7. What is the difference between the Unemployed and educated labor force (% of population) of OECD members in 2008 and the Unemployed and educated labor force (% of population) of Azerbaijan in 2010?
Give a very brief answer. 23.81. What is the difference between the Unemployed and educated labor force (% of population) in OECD members in 2008 and the Unemployed and educated labor force (% of population) in Panama in 2010?
Your response must be concise. 22.51. What is the difference between the Unemployed and educated labor force (% of population) in OECD members in 2008 and the Unemployed and educated labor force (% of population) in West Bank and Gaza in 2010?
Provide a short and direct response. -0.89. What is the difference between the Unemployed and educated labor force (% of population) in Azerbaijan in 2008 and the Unemployed and educated labor force (% of population) in Panama in 2010?
Your response must be concise. -4.2. What is the difference between the Unemployed and educated labor force (% of population) in Azerbaijan in 2008 and the Unemployed and educated labor force (% of population) in West Bank and Gaza in 2010?
Your answer should be very brief. -27.6. What is the difference between the Unemployed and educated labor force (% of population) of Panama in 2008 and the Unemployed and educated labor force (% of population) of West Bank and Gaza in 2010?
Give a very brief answer. -23. What is the difference between the Unemployed and educated labor force (% of population) of OECD members in 2009 and the Unemployed and educated labor force (% of population) of Azerbaijan in 2010?
Ensure brevity in your answer.  18.98. What is the difference between the Unemployed and educated labor force (% of population) in OECD members in 2009 and the Unemployed and educated labor force (% of population) in Panama in 2010?
Your response must be concise. 17.68. What is the difference between the Unemployed and educated labor force (% of population) in OECD members in 2009 and the Unemployed and educated labor force (% of population) in West Bank and Gaza in 2010?
Provide a short and direct response. -5.72. What is the difference between the Unemployed and educated labor force (% of population) of Azerbaijan in 2009 and the Unemployed and educated labor force (% of population) of Panama in 2010?
Make the answer very short. -3. What is the difference between the Unemployed and educated labor force (% of population) of Azerbaijan in 2009 and the Unemployed and educated labor force (% of population) of West Bank and Gaza in 2010?
Provide a short and direct response. -26.4. What is the difference between the Unemployed and educated labor force (% of population) in Panama in 2009 and the Unemployed and educated labor force (% of population) in West Bank and Gaza in 2010?
Make the answer very short. -23.1. What is the average Unemployed and educated labor force (% of population) of OECD members per year?
Give a very brief answer. 33.79. What is the average Unemployed and educated labor force (% of population) of Azerbaijan per year?
Ensure brevity in your answer.  7.44. What is the average Unemployed and educated labor force (% of population) of Panama per year?
Your answer should be compact. 23.7. What is the average Unemployed and educated labor force (% of population) of West Bank and Gaza per year?
Ensure brevity in your answer.  50.95. In the year 2003, what is the difference between the Unemployed and educated labor force (% of population) in OECD members and Unemployed and educated labor force (% of population) in Azerbaijan?
Offer a very short reply. 26.21. In the year 2003, what is the difference between the Unemployed and educated labor force (% of population) of OECD members and Unemployed and educated labor force (% of population) of Panama?
Keep it short and to the point. -0.79. In the year 2003, what is the difference between the Unemployed and educated labor force (% of population) of OECD members and Unemployed and educated labor force (% of population) of West Bank and Gaza?
Ensure brevity in your answer.  -22.49. In the year 2003, what is the difference between the Unemployed and educated labor force (% of population) of Azerbaijan and Unemployed and educated labor force (% of population) of West Bank and Gaza?
Your answer should be compact. -48.7. In the year 2003, what is the difference between the Unemployed and educated labor force (% of population) in Panama and Unemployed and educated labor force (% of population) in West Bank and Gaza?
Provide a short and direct response. -21.7. In the year 2004, what is the difference between the Unemployed and educated labor force (% of population) in OECD members and Unemployed and educated labor force (% of population) in Azerbaijan?
Provide a short and direct response. 28.32. In the year 2004, what is the difference between the Unemployed and educated labor force (% of population) of OECD members and Unemployed and educated labor force (% of population) of Panama?
Provide a short and direct response. -0.58. In the year 2004, what is the difference between the Unemployed and educated labor force (% of population) in OECD members and Unemployed and educated labor force (% of population) in West Bank and Gaza?
Provide a succinct answer. -23.78. In the year 2004, what is the difference between the Unemployed and educated labor force (% of population) in Azerbaijan and Unemployed and educated labor force (% of population) in Panama?
Offer a terse response. -28.9. In the year 2004, what is the difference between the Unemployed and educated labor force (% of population) in Azerbaijan and Unemployed and educated labor force (% of population) in West Bank and Gaza?
Make the answer very short. -52.1. In the year 2004, what is the difference between the Unemployed and educated labor force (% of population) in Panama and Unemployed and educated labor force (% of population) in West Bank and Gaza?
Give a very brief answer. -23.2. In the year 2005, what is the difference between the Unemployed and educated labor force (% of population) in OECD members and Unemployed and educated labor force (% of population) in Azerbaijan?
Your answer should be compact. 29.82. In the year 2005, what is the difference between the Unemployed and educated labor force (% of population) of OECD members and Unemployed and educated labor force (% of population) of Panama?
Keep it short and to the point. 2.92. In the year 2005, what is the difference between the Unemployed and educated labor force (% of population) of OECD members and Unemployed and educated labor force (% of population) of West Bank and Gaza?
Provide a succinct answer. -20.58. In the year 2005, what is the difference between the Unemployed and educated labor force (% of population) in Azerbaijan and Unemployed and educated labor force (% of population) in Panama?
Make the answer very short. -26.9. In the year 2005, what is the difference between the Unemployed and educated labor force (% of population) of Azerbaijan and Unemployed and educated labor force (% of population) of West Bank and Gaza?
Provide a short and direct response. -50.4. In the year 2005, what is the difference between the Unemployed and educated labor force (% of population) of Panama and Unemployed and educated labor force (% of population) of West Bank and Gaza?
Your answer should be very brief. -23.5. In the year 2006, what is the difference between the Unemployed and educated labor force (% of population) of OECD members and Unemployed and educated labor force (% of population) of Azerbaijan?
Provide a succinct answer. 31.91. In the year 2006, what is the difference between the Unemployed and educated labor force (% of population) in OECD members and Unemployed and educated labor force (% of population) in Panama?
Offer a terse response. 1.01. In the year 2006, what is the difference between the Unemployed and educated labor force (% of population) in OECD members and Unemployed and educated labor force (% of population) in West Bank and Gaza?
Give a very brief answer. -21.09. In the year 2006, what is the difference between the Unemployed and educated labor force (% of population) in Azerbaijan and Unemployed and educated labor force (% of population) in Panama?
Your answer should be very brief. -30.9. In the year 2006, what is the difference between the Unemployed and educated labor force (% of population) in Azerbaijan and Unemployed and educated labor force (% of population) in West Bank and Gaza?
Your response must be concise. -53. In the year 2006, what is the difference between the Unemployed and educated labor force (% of population) in Panama and Unemployed and educated labor force (% of population) in West Bank and Gaza?
Keep it short and to the point. -22.1. In the year 2007, what is the difference between the Unemployed and educated labor force (% of population) of OECD members and Unemployed and educated labor force (% of population) of Azerbaijan?
Your answer should be compact. 28.85. In the year 2007, what is the difference between the Unemployed and educated labor force (% of population) in OECD members and Unemployed and educated labor force (% of population) in Panama?
Your answer should be compact. 21.65. In the year 2007, what is the difference between the Unemployed and educated labor force (% of population) in OECD members and Unemployed and educated labor force (% of population) in West Bank and Gaza?
Ensure brevity in your answer.  -19.15. In the year 2007, what is the difference between the Unemployed and educated labor force (% of population) of Azerbaijan and Unemployed and educated labor force (% of population) of West Bank and Gaza?
Keep it short and to the point. -48. In the year 2007, what is the difference between the Unemployed and educated labor force (% of population) of Panama and Unemployed and educated labor force (% of population) of West Bank and Gaza?
Your response must be concise. -40.8. In the year 2008, what is the difference between the Unemployed and educated labor force (% of population) in OECD members and Unemployed and educated labor force (% of population) in Azerbaijan?
Your answer should be very brief. 26.71. In the year 2008, what is the difference between the Unemployed and educated labor force (% of population) of OECD members and Unemployed and educated labor force (% of population) of Panama?
Your answer should be compact. 22.11. In the year 2008, what is the difference between the Unemployed and educated labor force (% of population) in OECD members and Unemployed and educated labor force (% of population) in West Bank and Gaza?
Keep it short and to the point. -18.39. In the year 2008, what is the difference between the Unemployed and educated labor force (% of population) in Azerbaijan and Unemployed and educated labor force (% of population) in West Bank and Gaza?
Provide a short and direct response. -45.1. In the year 2008, what is the difference between the Unemployed and educated labor force (% of population) of Panama and Unemployed and educated labor force (% of population) of West Bank and Gaza?
Offer a terse response. -40.5. In the year 2009, what is the difference between the Unemployed and educated labor force (% of population) of OECD members and Unemployed and educated labor force (% of population) of Azerbaijan?
Provide a succinct answer. 20.68. In the year 2009, what is the difference between the Unemployed and educated labor force (% of population) of OECD members and Unemployed and educated labor force (% of population) of Panama?
Offer a terse response. 17.38. In the year 2009, what is the difference between the Unemployed and educated labor force (% of population) in OECD members and Unemployed and educated labor force (% of population) in West Bank and Gaza?
Ensure brevity in your answer.  -5.42. In the year 2009, what is the difference between the Unemployed and educated labor force (% of population) of Azerbaijan and Unemployed and educated labor force (% of population) of Panama?
Make the answer very short. -3.3. In the year 2009, what is the difference between the Unemployed and educated labor force (% of population) of Azerbaijan and Unemployed and educated labor force (% of population) of West Bank and Gaza?
Ensure brevity in your answer.  -26.1. In the year 2009, what is the difference between the Unemployed and educated labor force (% of population) of Panama and Unemployed and educated labor force (% of population) of West Bank and Gaza?
Your answer should be compact. -22.8. In the year 2010, what is the difference between the Unemployed and educated labor force (% of population) in OECD members and Unemployed and educated labor force (% of population) in Azerbaijan?
Offer a terse response. 18.29. In the year 2010, what is the difference between the Unemployed and educated labor force (% of population) in OECD members and Unemployed and educated labor force (% of population) in Panama?
Offer a terse response. 16.99. In the year 2010, what is the difference between the Unemployed and educated labor force (% of population) of OECD members and Unemployed and educated labor force (% of population) of West Bank and Gaza?
Ensure brevity in your answer.  -6.41. In the year 2010, what is the difference between the Unemployed and educated labor force (% of population) in Azerbaijan and Unemployed and educated labor force (% of population) in West Bank and Gaza?
Your answer should be very brief. -24.7. In the year 2010, what is the difference between the Unemployed and educated labor force (% of population) in Panama and Unemployed and educated labor force (% of population) in West Bank and Gaza?
Offer a terse response. -23.4. What is the ratio of the Unemployed and educated labor force (% of population) in OECD members in 2003 to that in 2004?
Your answer should be very brief. 1.01. What is the ratio of the Unemployed and educated labor force (% of population) of Azerbaijan in 2003 to that in 2004?
Offer a very short reply. 1.39. What is the ratio of the Unemployed and educated labor force (% of population) of West Bank and Gaza in 2003 to that in 2004?
Your answer should be very brief. 0.98. What is the ratio of the Unemployed and educated labor force (% of population) in OECD members in 2003 to that in 2005?
Provide a succinct answer. 1.01. What is the ratio of the Unemployed and educated labor force (% of population) of Azerbaijan in 2003 to that in 2005?
Ensure brevity in your answer.  1.85. What is the ratio of the Unemployed and educated labor force (% of population) of Panama in 2003 to that in 2005?
Your response must be concise. 1.13. What is the ratio of the Unemployed and educated labor force (% of population) of West Bank and Gaza in 2003 to that in 2005?
Provide a short and direct response. 1.04. What is the ratio of the Unemployed and educated labor force (% of population) in OECD members in 2003 to that in 2006?
Provide a succinct answer. 1.01. What is the ratio of the Unemployed and educated labor force (% of population) in Azerbaijan in 2003 to that in 2006?
Keep it short and to the point. 3.07. What is the ratio of the Unemployed and educated labor force (% of population) of Panama in 2003 to that in 2006?
Your answer should be compact. 1.06. What is the ratio of the Unemployed and educated labor force (% of population) in West Bank and Gaza in 2003 to that in 2006?
Make the answer very short. 1.03. What is the ratio of the Unemployed and educated labor force (% of population) of OECD members in 2003 to that in 2007?
Provide a short and direct response. 1. What is the ratio of the Unemployed and educated labor force (% of population) in Azerbaijan in 2003 to that in 2007?
Offer a terse response. 1.41. What is the ratio of the Unemployed and educated labor force (% of population) in Panama in 2003 to that in 2007?
Give a very brief answer. 2.66. What is the ratio of the Unemployed and educated labor force (% of population) of West Bank and Gaza in 2003 to that in 2007?
Keep it short and to the point. 1.06. What is the ratio of the Unemployed and educated labor force (% of population) in OECD members in 2003 to that in 2008?
Provide a succinct answer. 0.99. What is the ratio of the Unemployed and educated labor force (% of population) of Azerbaijan in 2003 to that in 2008?
Keep it short and to the point. 1.02. What is the ratio of the Unemployed and educated labor force (% of population) of Panama in 2003 to that in 2008?
Your answer should be compact. 2.7. What is the ratio of the Unemployed and educated labor force (% of population) of West Bank and Gaza in 2003 to that in 2008?
Provide a succinct answer. 1.07. What is the ratio of the Unemployed and educated labor force (% of population) in OECD members in 2003 to that in 2009?
Your answer should be compact. 1.15. What is the ratio of the Unemployed and educated labor force (% of population) of Azerbaijan in 2003 to that in 2009?
Offer a terse response. 0.9. What is the ratio of the Unemployed and educated labor force (% of population) in Panama in 2003 to that in 2009?
Offer a very short reply. 2.72. What is the ratio of the Unemployed and educated labor force (% of population) of West Bank and Gaza in 2003 to that in 2009?
Your answer should be compact. 1.6. What is the ratio of the Unemployed and educated labor force (% of population) in OECD members in 2003 to that in 2010?
Offer a terse response. 1.17. What is the ratio of the Unemployed and educated labor force (% of population) of Azerbaijan in 2003 to that in 2010?
Provide a succinct answer. 0.77. What is the ratio of the Unemployed and educated labor force (% of population) in Panama in 2003 to that in 2010?
Offer a very short reply. 2.78. What is the ratio of the Unemployed and educated labor force (% of population) in West Bank and Gaza in 2003 to that in 2010?
Keep it short and to the point. 1.59. What is the ratio of the Unemployed and educated labor force (% of population) in OECD members in 2004 to that in 2005?
Provide a succinct answer. 1. What is the ratio of the Unemployed and educated labor force (% of population) in Panama in 2004 to that in 2005?
Your response must be concise. 1.11. What is the ratio of the Unemployed and educated labor force (% of population) in West Bank and Gaza in 2004 to that in 2005?
Your response must be concise. 1.06. What is the ratio of the Unemployed and educated labor force (% of population) in OECD members in 2004 to that in 2006?
Ensure brevity in your answer.  1. What is the ratio of the Unemployed and educated labor force (% of population) in Azerbaijan in 2004 to that in 2006?
Provide a succinct answer. 2.21. What is the ratio of the Unemployed and educated labor force (% of population) in Panama in 2004 to that in 2006?
Your response must be concise. 1.04. What is the ratio of the Unemployed and educated labor force (% of population) in West Bank and Gaza in 2004 to that in 2006?
Your answer should be very brief. 1.05. What is the ratio of the Unemployed and educated labor force (% of population) in Azerbaijan in 2004 to that in 2007?
Offer a terse response. 1.02. What is the ratio of the Unemployed and educated labor force (% of population) of Panama in 2004 to that in 2007?
Your answer should be compact. 2.61. What is the ratio of the Unemployed and educated labor force (% of population) in West Bank and Gaza in 2004 to that in 2007?
Your answer should be very brief. 1.08. What is the ratio of the Unemployed and educated labor force (% of population) of OECD members in 2004 to that in 2008?
Ensure brevity in your answer.  0.98. What is the ratio of the Unemployed and educated labor force (% of population) of Azerbaijan in 2004 to that in 2008?
Make the answer very short. 0.74. What is the ratio of the Unemployed and educated labor force (% of population) in Panama in 2004 to that in 2008?
Your response must be concise. 2.65. What is the ratio of the Unemployed and educated labor force (% of population) in West Bank and Gaza in 2004 to that in 2008?
Your response must be concise. 1.09. What is the ratio of the Unemployed and educated labor force (% of population) in OECD members in 2004 to that in 2009?
Give a very brief answer. 1.14. What is the ratio of the Unemployed and educated labor force (% of population) of Azerbaijan in 2004 to that in 2009?
Your response must be concise. 0.65. What is the ratio of the Unemployed and educated labor force (% of population) of Panama in 2004 to that in 2009?
Your answer should be very brief. 2.67. What is the ratio of the Unemployed and educated labor force (% of population) of West Bank and Gaza in 2004 to that in 2009?
Offer a very short reply. 1.62. What is the ratio of the Unemployed and educated labor force (% of population) in OECD members in 2004 to that in 2010?
Your response must be concise. 1.16. What is the ratio of the Unemployed and educated labor force (% of population) of Azerbaijan in 2004 to that in 2010?
Offer a very short reply. 0.55. What is the ratio of the Unemployed and educated labor force (% of population) in Panama in 2004 to that in 2010?
Offer a terse response. 2.74. What is the ratio of the Unemployed and educated labor force (% of population) of West Bank and Gaza in 2004 to that in 2010?
Provide a succinct answer. 1.61. What is the ratio of the Unemployed and educated labor force (% of population) of OECD members in 2005 to that in 2006?
Offer a terse response. 0.99. What is the ratio of the Unemployed and educated labor force (% of population) of Azerbaijan in 2005 to that in 2006?
Offer a terse response. 1.66. What is the ratio of the Unemployed and educated labor force (% of population) in Panama in 2005 to that in 2006?
Keep it short and to the point. 0.94. What is the ratio of the Unemployed and educated labor force (% of population) in West Bank and Gaza in 2005 to that in 2006?
Give a very brief answer. 0.99. What is the ratio of the Unemployed and educated labor force (% of population) in OECD members in 2005 to that in 2007?
Ensure brevity in your answer.  0.98. What is the ratio of the Unemployed and educated labor force (% of population) in Azerbaijan in 2005 to that in 2007?
Ensure brevity in your answer.  0.76. What is the ratio of the Unemployed and educated labor force (% of population) of Panama in 2005 to that in 2007?
Provide a succinct answer. 2.35. What is the ratio of the Unemployed and educated labor force (% of population) in West Bank and Gaza in 2005 to that in 2007?
Provide a short and direct response. 1.02. What is the ratio of the Unemployed and educated labor force (% of population) of OECD members in 2005 to that in 2008?
Ensure brevity in your answer.  0.98. What is the ratio of the Unemployed and educated labor force (% of population) in Azerbaijan in 2005 to that in 2008?
Make the answer very short. 0.55. What is the ratio of the Unemployed and educated labor force (% of population) of Panama in 2005 to that in 2008?
Your answer should be compact. 2.38. What is the ratio of the Unemployed and educated labor force (% of population) in OECD members in 2005 to that in 2009?
Provide a succinct answer. 1.13. What is the ratio of the Unemployed and educated labor force (% of population) of Azerbaijan in 2005 to that in 2009?
Ensure brevity in your answer.  0.48. What is the ratio of the Unemployed and educated labor force (% of population) of Panama in 2005 to that in 2009?
Give a very brief answer. 2.4. What is the ratio of the Unemployed and educated labor force (% of population) in West Bank and Gaza in 2005 to that in 2009?
Provide a short and direct response. 1.53. What is the ratio of the Unemployed and educated labor force (% of population) in OECD members in 2005 to that in 2010?
Offer a very short reply. 1.16. What is the ratio of the Unemployed and educated labor force (% of population) of Azerbaijan in 2005 to that in 2010?
Offer a terse response. 0.41. What is the ratio of the Unemployed and educated labor force (% of population) of Panama in 2005 to that in 2010?
Provide a short and direct response. 2.46. What is the ratio of the Unemployed and educated labor force (% of population) in West Bank and Gaza in 2005 to that in 2010?
Your answer should be compact. 1.52. What is the ratio of the Unemployed and educated labor force (% of population) in Azerbaijan in 2006 to that in 2007?
Your response must be concise. 0.46. What is the ratio of the Unemployed and educated labor force (% of population) of Panama in 2006 to that in 2007?
Your answer should be very brief. 2.5. What is the ratio of the Unemployed and educated labor force (% of population) in West Bank and Gaza in 2006 to that in 2007?
Your answer should be compact. 1.03. What is the ratio of the Unemployed and educated labor force (% of population) in OECD members in 2006 to that in 2008?
Provide a succinct answer. 0.98. What is the ratio of the Unemployed and educated labor force (% of population) in Panama in 2006 to that in 2008?
Provide a succinct answer. 2.54. What is the ratio of the Unemployed and educated labor force (% of population) in West Bank and Gaza in 2006 to that in 2008?
Make the answer very short. 1.04. What is the ratio of the Unemployed and educated labor force (% of population) of OECD members in 2006 to that in 2009?
Ensure brevity in your answer.  1.14. What is the ratio of the Unemployed and educated labor force (% of population) in Azerbaijan in 2006 to that in 2009?
Offer a very short reply. 0.29. What is the ratio of the Unemployed and educated labor force (% of population) of Panama in 2006 to that in 2009?
Make the answer very short. 2.56. What is the ratio of the Unemployed and educated labor force (% of population) in West Bank and Gaza in 2006 to that in 2009?
Offer a very short reply. 1.55. What is the ratio of the Unemployed and educated labor force (% of population) in OECD members in 2006 to that in 2010?
Ensure brevity in your answer.  1.16. What is the ratio of the Unemployed and educated labor force (% of population) in Azerbaijan in 2006 to that in 2010?
Keep it short and to the point. 0.25. What is the ratio of the Unemployed and educated labor force (% of population) in Panama in 2006 to that in 2010?
Ensure brevity in your answer.  2.62. What is the ratio of the Unemployed and educated labor force (% of population) of West Bank and Gaza in 2006 to that in 2010?
Provide a short and direct response. 1.54. What is the ratio of the Unemployed and educated labor force (% of population) of OECD members in 2007 to that in 2008?
Give a very brief answer. 0.99. What is the ratio of the Unemployed and educated labor force (% of population) in Azerbaijan in 2007 to that in 2008?
Your answer should be compact. 0.72. What is the ratio of the Unemployed and educated labor force (% of population) in West Bank and Gaza in 2007 to that in 2008?
Your response must be concise. 1.01. What is the ratio of the Unemployed and educated labor force (% of population) of OECD members in 2007 to that in 2009?
Offer a terse response. 1.15. What is the ratio of the Unemployed and educated labor force (% of population) of Azerbaijan in 2007 to that in 2009?
Make the answer very short. 0.64. What is the ratio of the Unemployed and educated labor force (% of population) in Panama in 2007 to that in 2009?
Your answer should be very brief. 1.02. What is the ratio of the Unemployed and educated labor force (% of population) of West Bank and Gaza in 2007 to that in 2009?
Ensure brevity in your answer.  1.51. What is the ratio of the Unemployed and educated labor force (% of population) of OECD members in 2007 to that in 2010?
Provide a short and direct response. 1.18. What is the ratio of the Unemployed and educated labor force (% of population) in Azerbaijan in 2007 to that in 2010?
Give a very brief answer. 0.54. What is the ratio of the Unemployed and educated labor force (% of population) in Panama in 2007 to that in 2010?
Your response must be concise. 1.05. What is the ratio of the Unemployed and educated labor force (% of population) in West Bank and Gaza in 2007 to that in 2010?
Make the answer very short. 1.5. What is the ratio of the Unemployed and educated labor force (% of population) of OECD members in 2008 to that in 2009?
Your answer should be very brief. 1.16. What is the ratio of the Unemployed and educated labor force (% of population) in Azerbaijan in 2008 to that in 2009?
Provide a succinct answer. 0.88. What is the ratio of the Unemployed and educated labor force (% of population) in Panama in 2008 to that in 2009?
Offer a very short reply. 1.01. What is the ratio of the Unemployed and educated labor force (% of population) in West Bank and Gaza in 2008 to that in 2009?
Your response must be concise. 1.49. What is the ratio of the Unemployed and educated labor force (% of population) of OECD members in 2008 to that in 2010?
Give a very brief answer. 1.18. What is the ratio of the Unemployed and educated labor force (% of population) of Azerbaijan in 2008 to that in 2010?
Give a very brief answer. 0.75. What is the ratio of the Unemployed and educated labor force (% of population) of Panama in 2008 to that in 2010?
Offer a very short reply. 1.03. What is the ratio of the Unemployed and educated labor force (% of population) in West Bank and Gaza in 2008 to that in 2010?
Ensure brevity in your answer.  1.48. What is the ratio of the Unemployed and educated labor force (% of population) of Azerbaijan in 2009 to that in 2010?
Offer a very short reply. 0.85. What is the ratio of the Unemployed and educated labor force (% of population) of Panama in 2009 to that in 2010?
Offer a terse response. 1.02. What is the difference between the highest and the second highest Unemployed and educated labor force (% of population) of OECD members?
Your response must be concise. 0.26. What is the difference between the highest and the lowest Unemployed and educated labor force (% of population) of OECD members?
Ensure brevity in your answer.  5.51. What is the difference between the highest and the lowest Unemployed and educated labor force (% of population) of Azerbaijan?
Your answer should be very brief. 8.7. What is the difference between the highest and the lowest Unemployed and educated labor force (% of population) in Panama?
Provide a short and direct response. 23. 